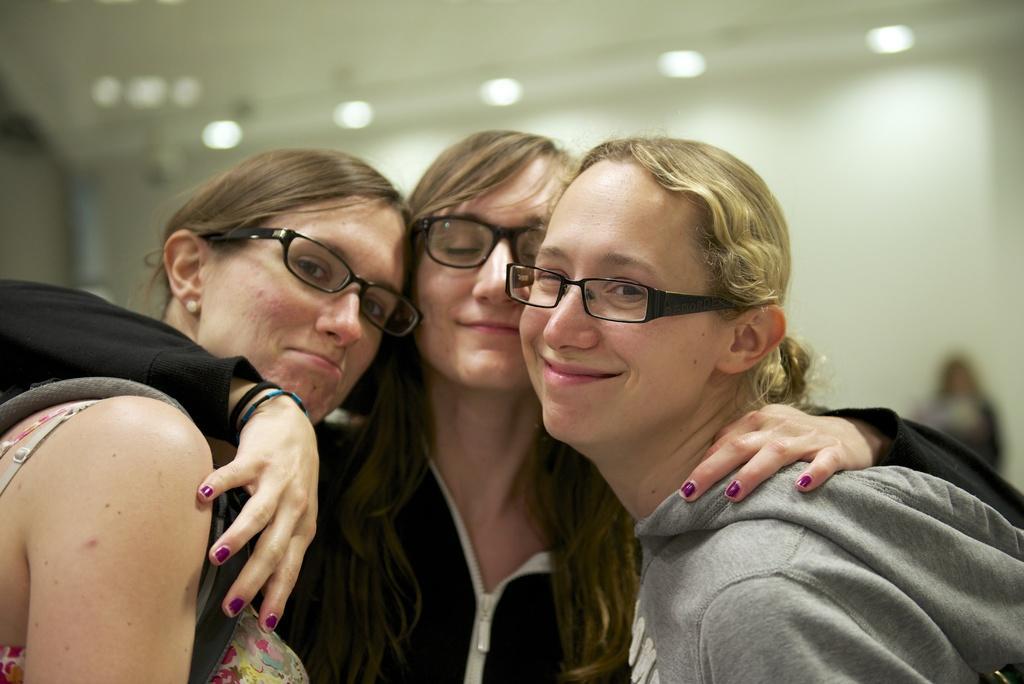Could you give a brief overview of what you see in this image? In this image we can see a few people. There are are few lights attached to the roof. 